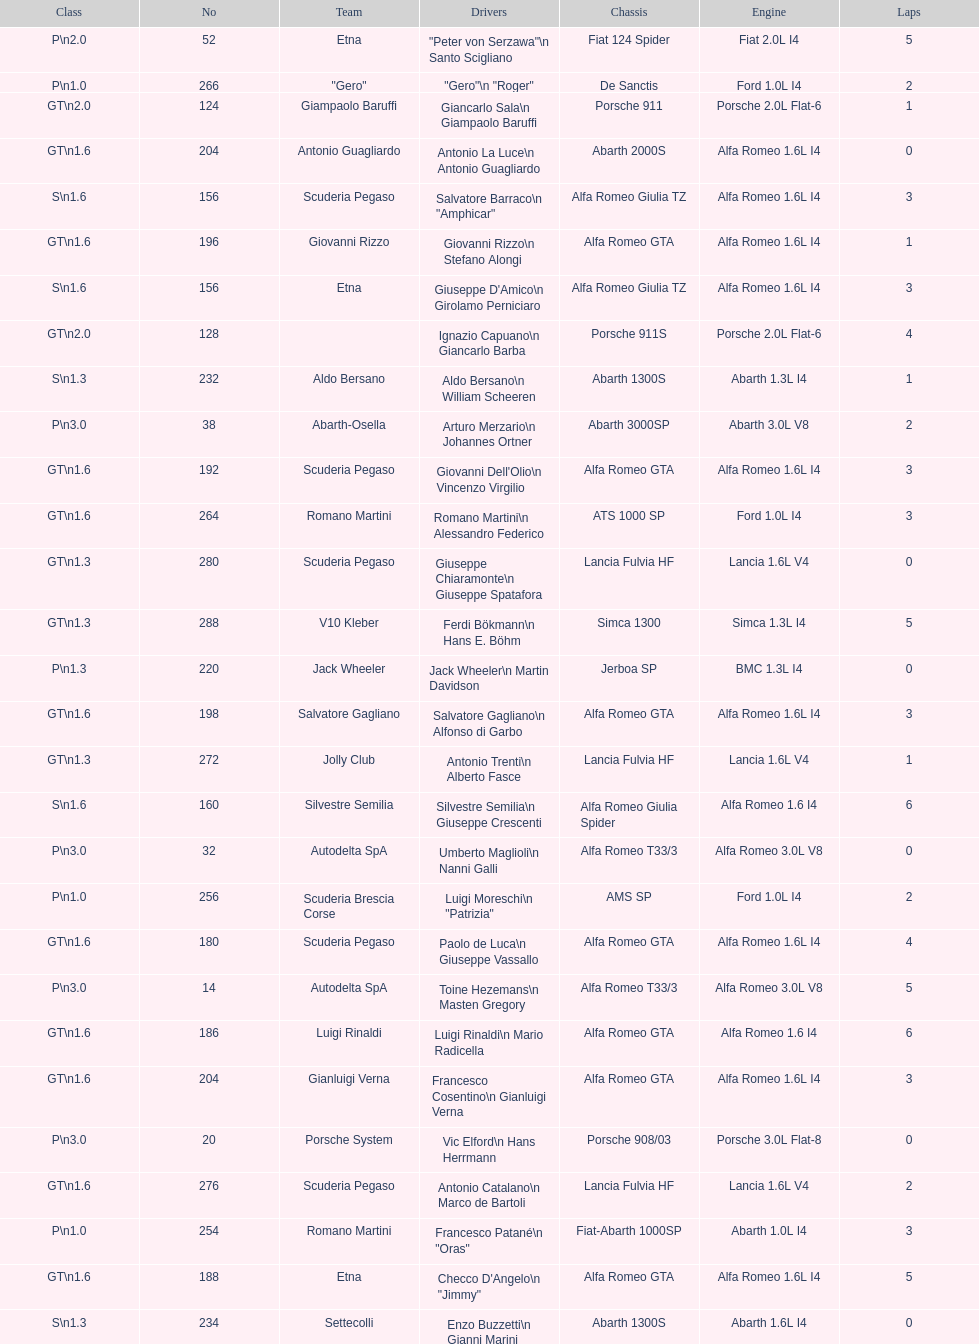How many teams did not finish the race after 2 laps? 4. 